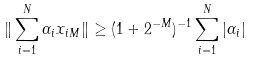<formula> <loc_0><loc_0><loc_500><loc_500>\| \sum _ { i = 1 } ^ { N } \alpha _ { i } x _ { i M } \| \geq ( 1 + 2 ^ { - M } ) ^ { - 1 } \sum _ { i = 1 } ^ { N } | \alpha _ { i } |</formula> 